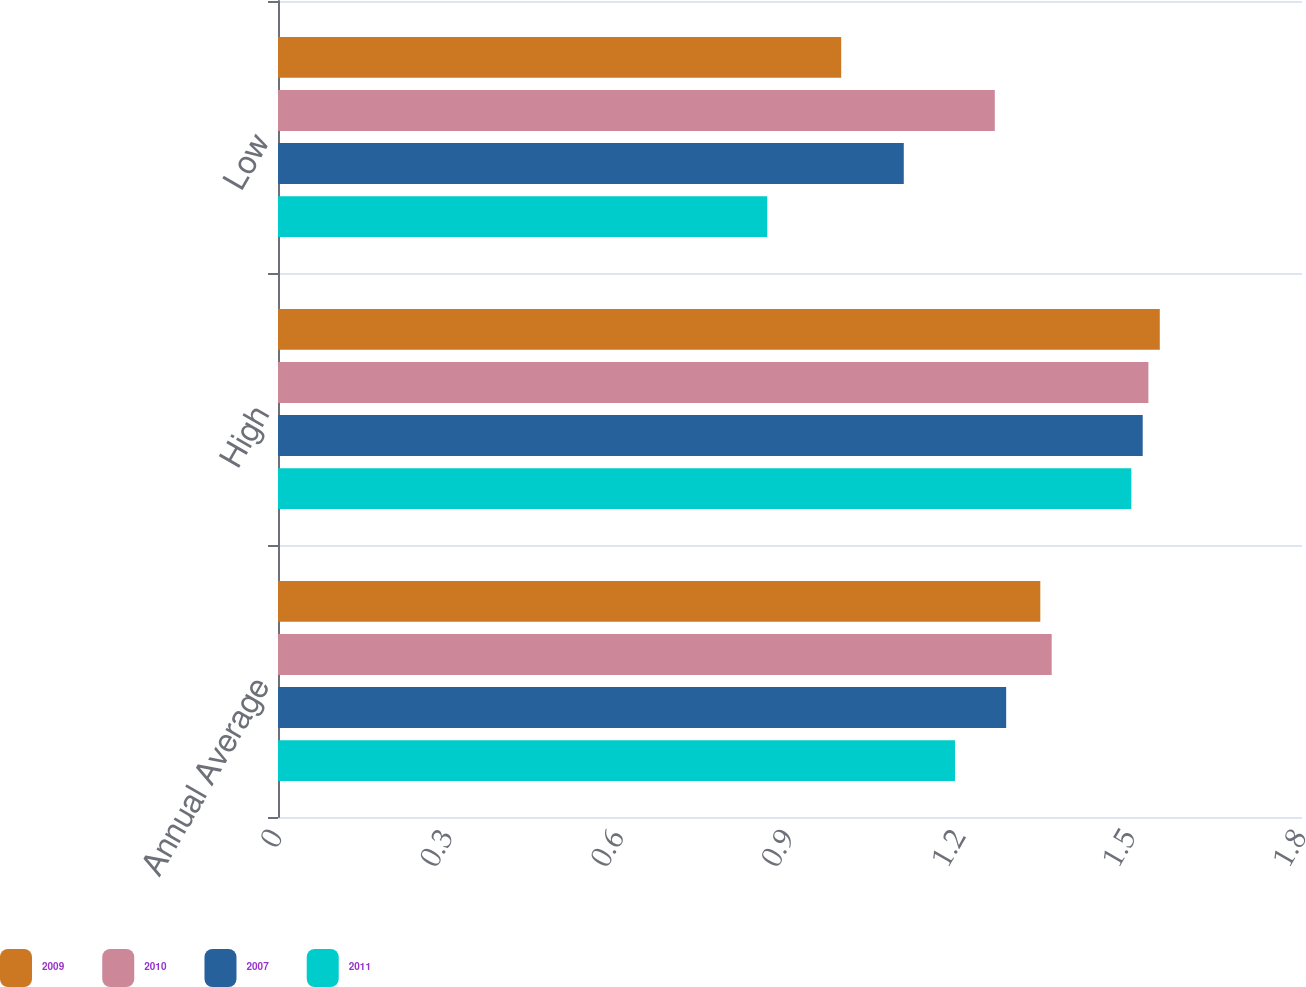<chart> <loc_0><loc_0><loc_500><loc_500><stacked_bar_chart><ecel><fcel>Annual Average<fcel>High<fcel>Low<nl><fcel>2009<fcel>1.34<fcel>1.55<fcel>0.99<nl><fcel>2010<fcel>1.36<fcel>1.53<fcel>1.26<nl><fcel>2007<fcel>1.28<fcel>1.52<fcel>1.1<nl><fcel>2011<fcel>1.19<fcel>1.5<fcel>0.86<nl></chart> 